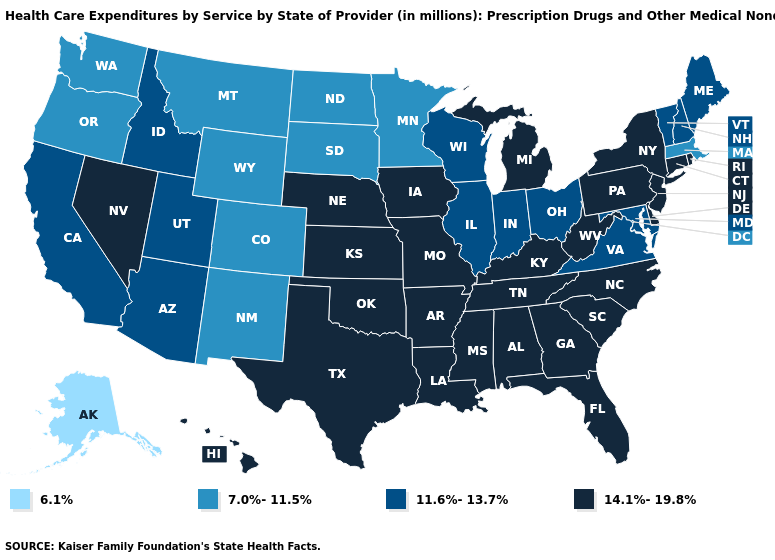What is the value of New Hampshire?
Answer briefly. 11.6%-13.7%. Which states have the highest value in the USA?
Short answer required. Alabama, Arkansas, Connecticut, Delaware, Florida, Georgia, Hawaii, Iowa, Kansas, Kentucky, Louisiana, Michigan, Mississippi, Missouri, Nebraska, Nevada, New Jersey, New York, North Carolina, Oklahoma, Pennsylvania, Rhode Island, South Carolina, Tennessee, Texas, West Virginia. Which states hav the highest value in the MidWest?
Concise answer only. Iowa, Kansas, Michigan, Missouri, Nebraska. What is the value of Wyoming?
Give a very brief answer. 7.0%-11.5%. What is the highest value in states that border Nebraska?
Give a very brief answer. 14.1%-19.8%. What is the value of Pennsylvania?
Short answer required. 14.1%-19.8%. Among the states that border Vermont , does New Hampshire have the highest value?
Write a very short answer. No. Among the states that border Rhode Island , does Connecticut have the lowest value?
Short answer required. No. What is the highest value in the USA?
Short answer required. 14.1%-19.8%. Does Mississippi have the lowest value in the South?
Short answer required. No. Among the states that border Washington , does Idaho have the highest value?
Write a very short answer. Yes. Does Alabama have the highest value in the USA?
Short answer required. Yes. What is the highest value in states that border West Virginia?
Write a very short answer. 14.1%-19.8%. What is the value of Alaska?
Quick response, please. 6.1%. 